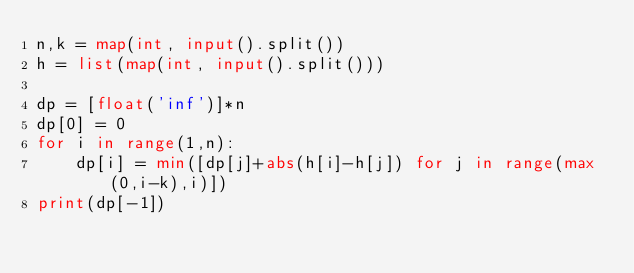Convert code to text. <code><loc_0><loc_0><loc_500><loc_500><_Python_>n,k = map(int, input().split())
h = list(map(int, input().split()))

dp = [float('inf')]*n
dp[0] = 0
for i in range(1,n):
    dp[i] = min([dp[j]+abs(h[i]-h[j]) for j in range(max(0,i-k),i)])
print(dp[-1])</code> 